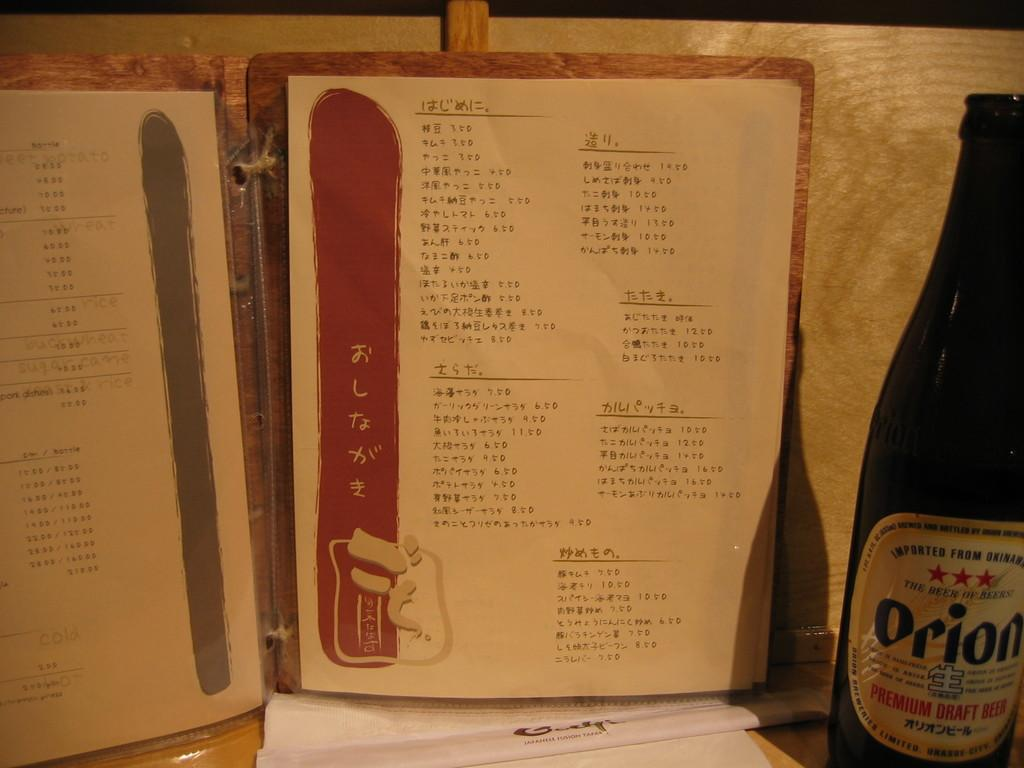<image>
Give a short and clear explanation of the subsequent image. A Chinese menu is on a table with a bottle of Orion premium draft beer. 